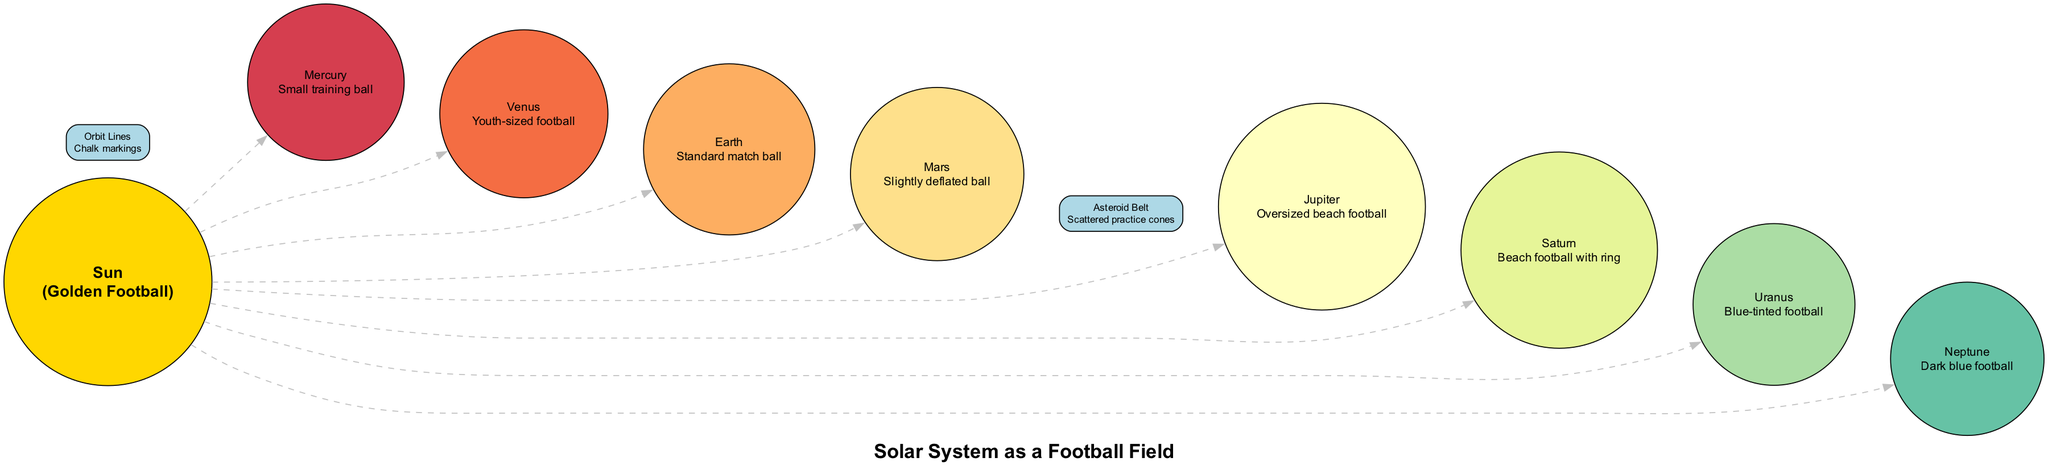What is the largest planet in the diagram? The diagram lists all planets, and by comparing their descriptions, Jupiter is depicted as an "Oversized beach football," making it the largest.
Answer: Jupiter How many planets are shown in the diagram? The diagram contains a list of planets, which includes Mercury, Venus, Earth, Mars, Jupiter, Saturn, Uranus, and Neptune. This totals to 8 planets.
Answer: 8 What is the description of Mars? The diagram provides the description for Mars as a "Slightly deflated ball," which is explicitly stated in its entry.
Answer: Slightly deflated ball Which planet is represented by the blue-tinted football? The diagram states that Uranus is depicted as a "Blue-tinted football," thus providing a clear association with that description.
Answer: Uranus What is the purpose of the Asteroid Belt in the solar system diagram? The Asteroid Belt is visually represented as "Scattered practice cones," indicating its role as a space filled with many small objects, analogous to practice cones being scattered around.
Answer: Scattered practice cones In the diagram, which planet is closest to the Sun? By the arrangement of planets in terms of connections, Mercury is connected directly to the Sun, indicating it is the closest planet.
Answer: Mercury What visual element indicates the paths of the planets? The diagram includes "Chalk markings" as the Orbit Lines, which represent the paths that the planets take around the Sun.
Answer: Chalk markings Which planet has a ring depicted in the diagram? The diagram refers to Saturn as a "Beach football with ring," indicating that it is the planet depicted with a ring.
Answer: Saturn What type of ball represents Earth? Earth is described as a "Standard match ball" in the diagram, providing clear information about its representation.
Answer: Standard match ball 